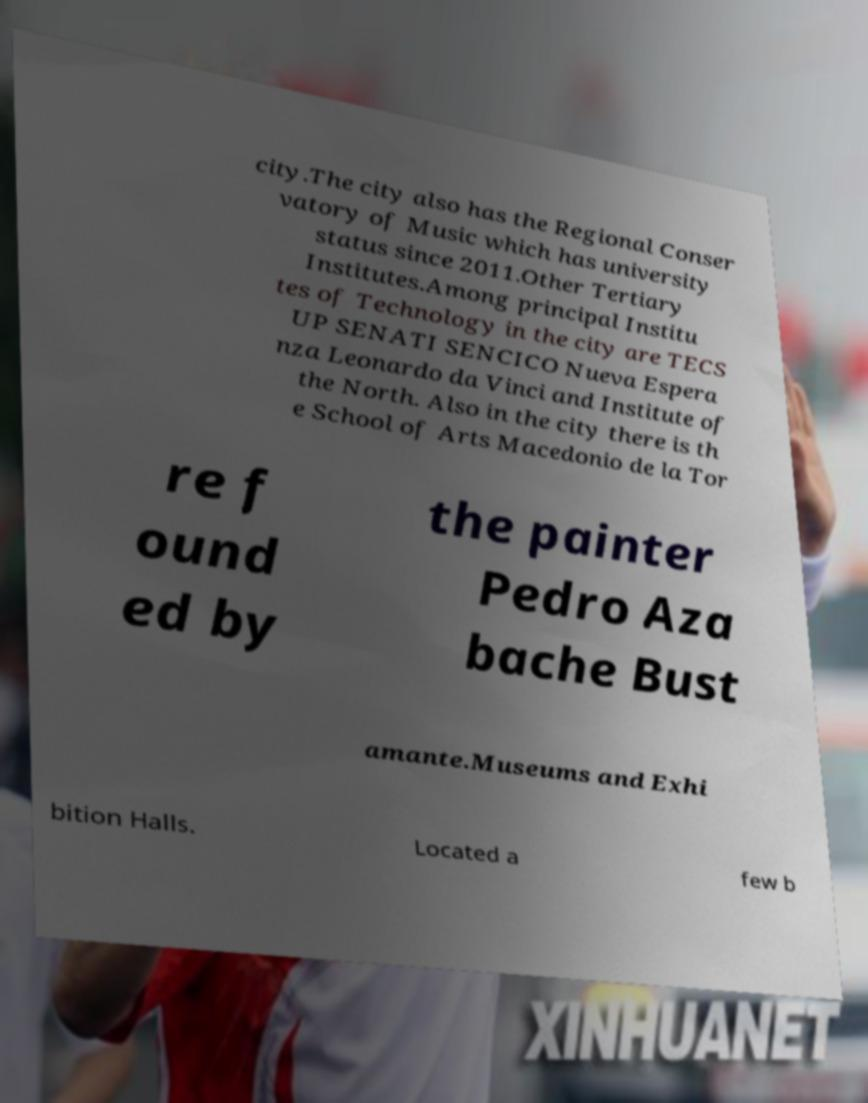Please read and relay the text visible in this image. What does it say? city.The city also has the Regional Conser vatory of Music which has university status since 2011.Other Tertiary Institutes.Among principal Institu tes of Technology in the city are TECS UP SENATI SENCICO Nueva Espera nza Leonardo da Vinci and Institute of the North. Also in the city there is th e School of Arts Macedonio de la Tor re f ound ed by the painter Pedro Aza bache Bust amante.Museums and Exhi bition Halls. Located a few b 